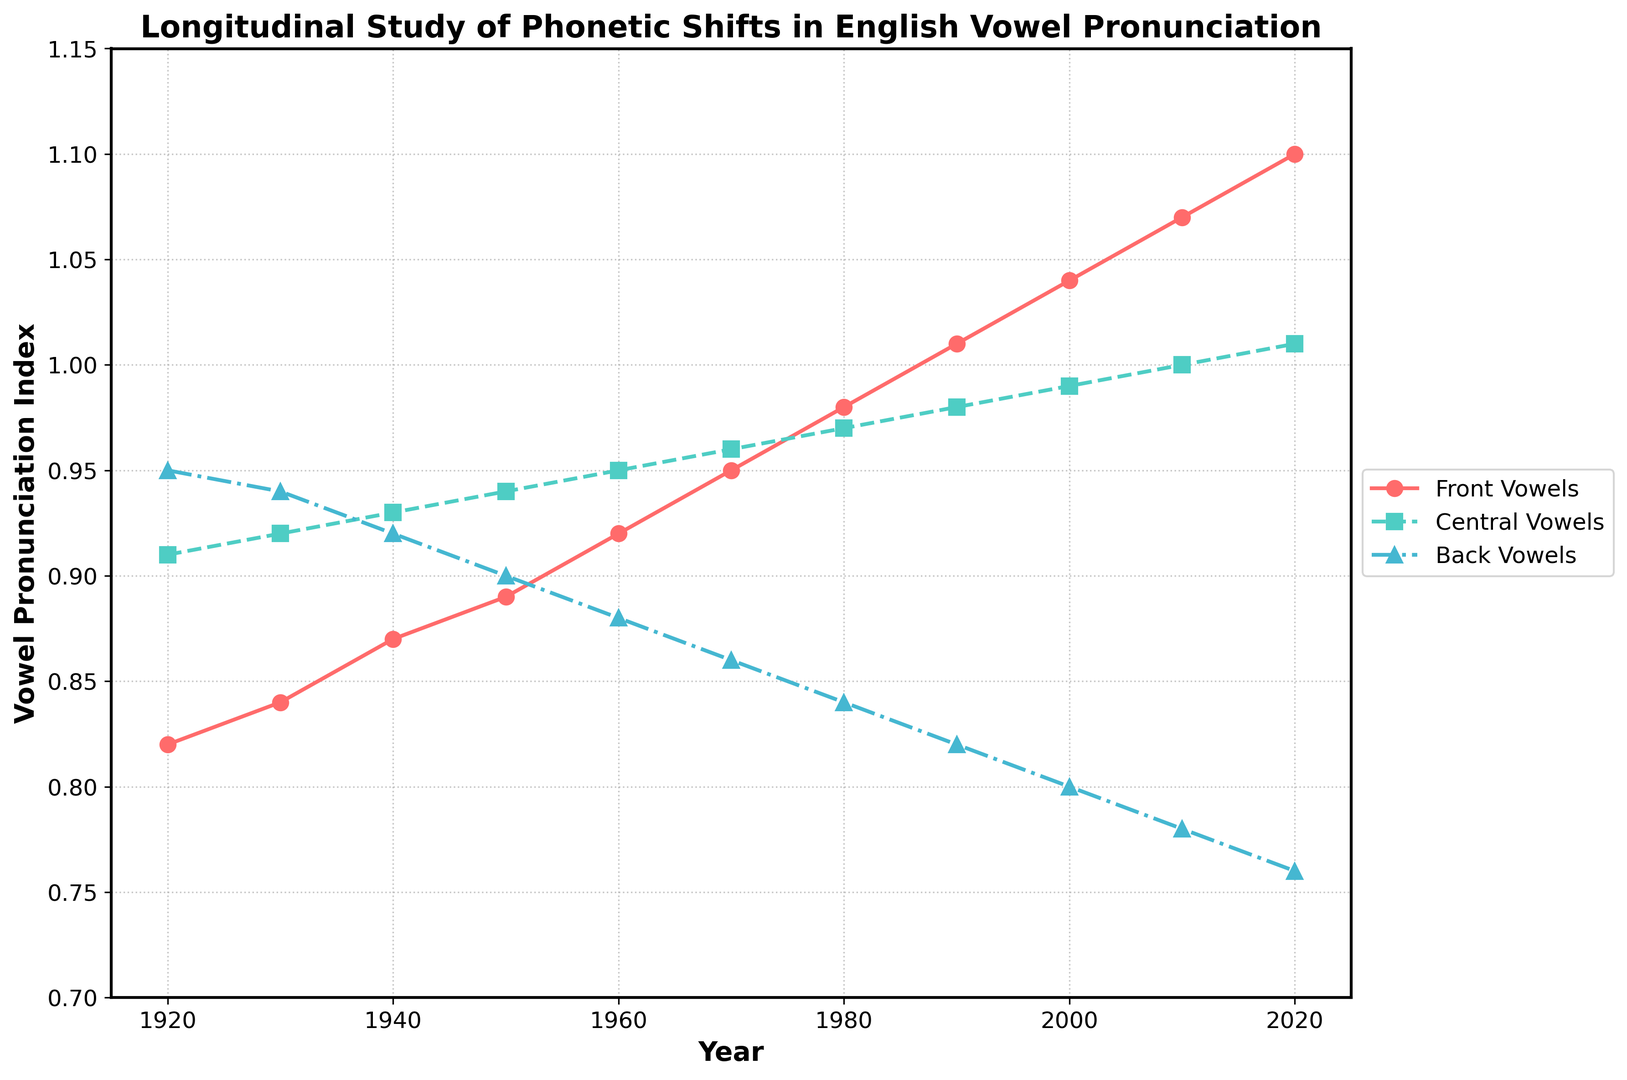What trends do you notice in the pronunciation index of front vowels over the years? The pronunciation index of front vowels shows a consistent upward trend from 1920 to 2020. It starts at 0.82 in 1920 and increases steadily, reaching 1.10 by 2020.
Answer: Consistent upward trend How did the pronunciation index of central vowels change from 1950 to 1980? In 1950, the pronunciation index for central vowels was 0.94. By 1980, it had risen to 0.97. The index increased incrementally each decade within this period, with increases of 0.01 per decade.
Answer: Increased by 0.03 Which type of vowel has shown the most significant decrease in pronunciation index over these years? The back vowels show the most significant decrease over the years. Beginning at 0.95 in 1920, the index declines steadily to 0.76 by 2020.
Answer: Back vowels Which vowel type crosses the 1.00 pronunciation index threshold first and when? The central vowels reach the 1.00 threshold first in 2010. This can be seen by comparing the numeric values across the years.
Answer: Central vowels, in 2010 By how much did the pronunciation index of back vowels change between 1920 and 2020, and what is the average decrease per decade? The pronunciation index for back vowels dropped from 0.95 in 1920 to 0.76 in 2020, a total decrease of 0.19. The period covered is 10 decades, so the average decrease per decade is 0.19/10, which is 0.019.
Answer: Decreased by 0.19, average decrease 0.019 per decade Compare the trends of front vowels and central vowels. Which had a more stable increase? Both front and central vowels show an upward trend, but the central vowels exhibit a more stable and gradual increase from 0.91 in 1920 to 1.01 in 2020, with no significant abrupt changes.
Answer: Central vowels In which decade did the front vowels surpass the 1.00 pronunciation index? The front vowels surpassed the 1.00 pronunciation index in the decade between 1990 and 2000. Specifically, the index was 1.01 in 1990 and 1.04 in 2000.
Answer: Between 1990 and 2000 What are the notable visual differences in the plot lines of front, central, and back vowels? The front vowels are represented with a solid line and circle markers in red, showing a steep incline. Central vowels have a dashed line with square markers in green, indicating a steadier upward trajectory. Back vowels are plotted with a dash-dot line and triangle markers in blue, depicting a gradual decline.
Answer: Front vowels: steep incline, red; Central vowels: steady increase, green; Back vowels: gradual decline, blue 